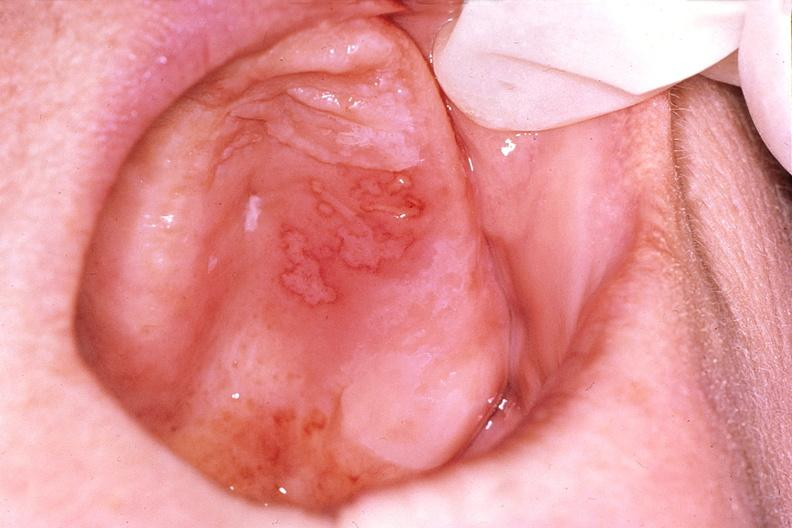what does this image show?
Answer the question using a single word or phrase. Mouth 